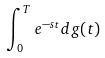Convert formula to latex. <formula><loc_0><loc_0><loc_500><loc_500>\int _ { 0 } ^ { T } e ^ { - s t } d g ( t )</formula> 